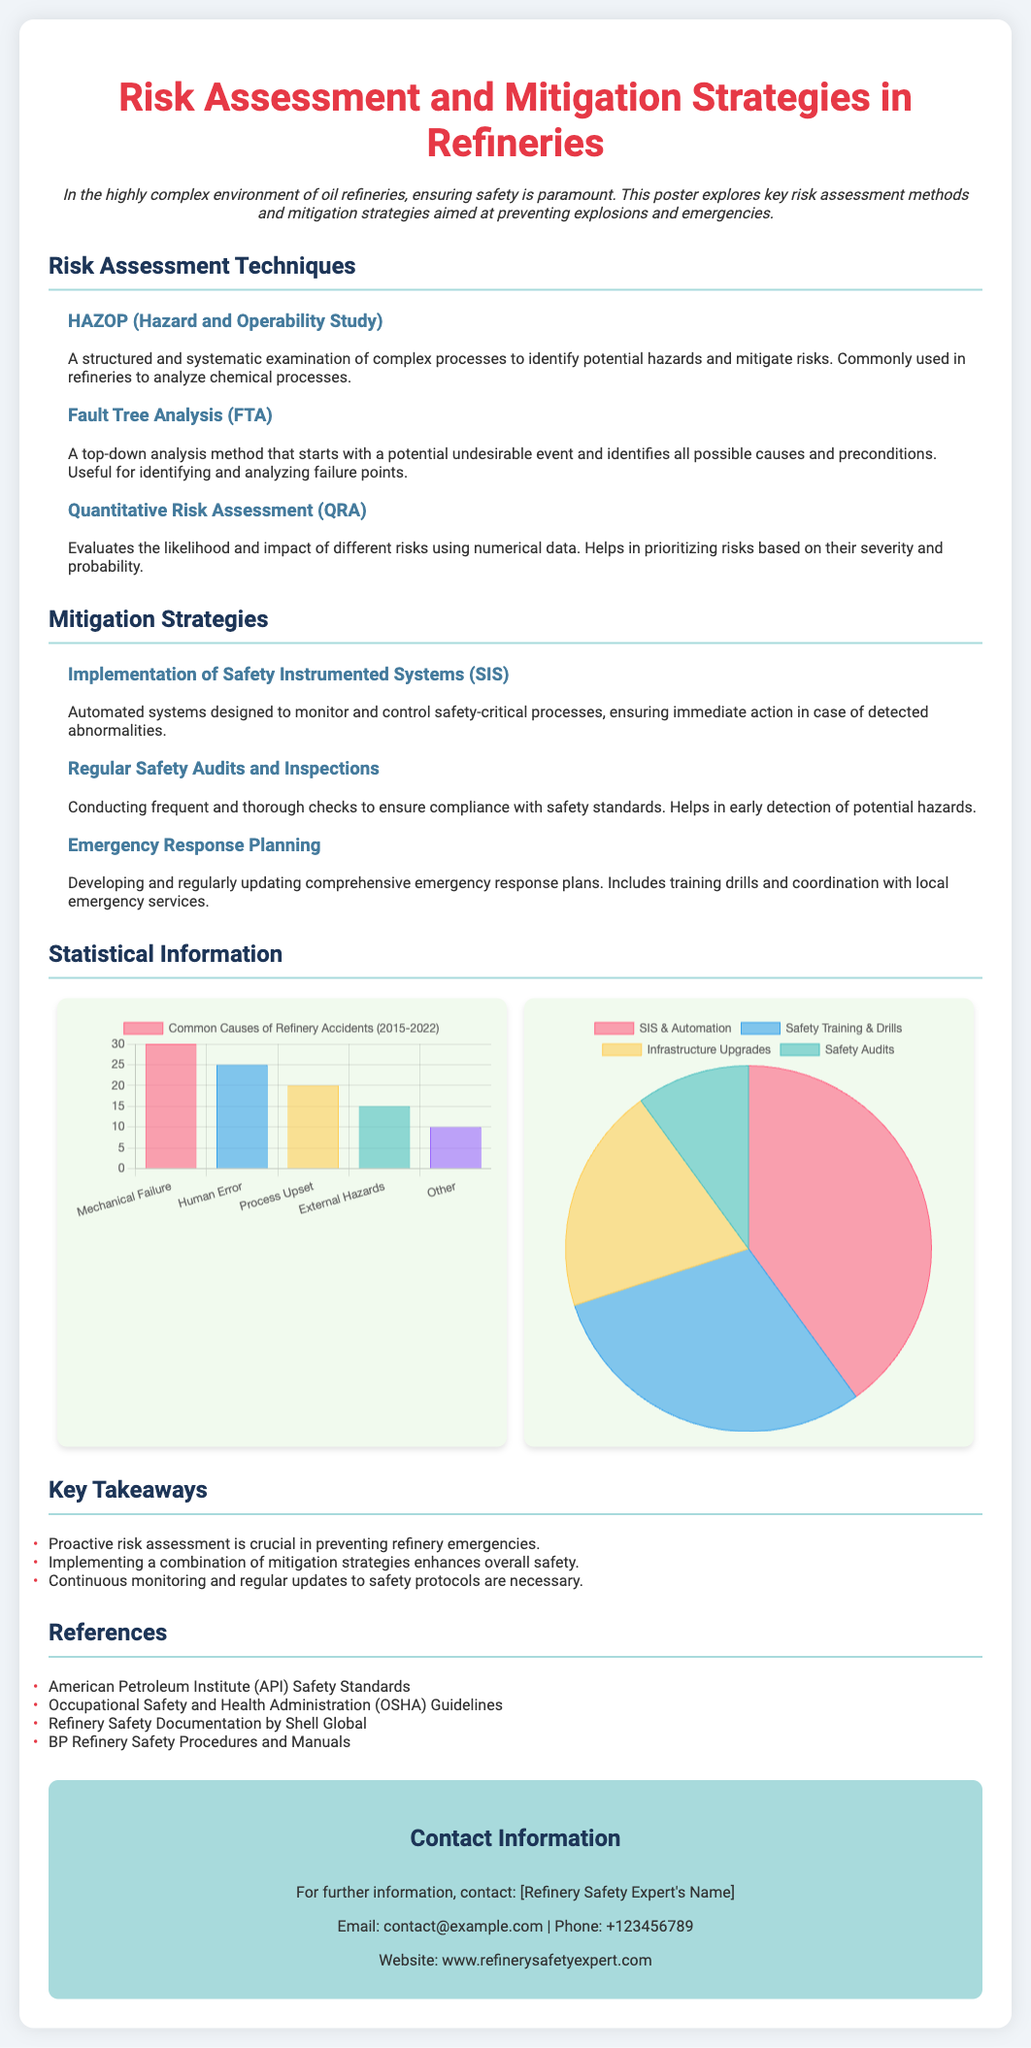What are the three risk assessment techniques mentioned? The poster lists HAZOP, Fault Tree Analysis (FTA), and Quantitative Risk Assessment (QRA) as the three risk assessment techniques.
Answer: HAZOP, Fault Tree Analysis (FTA), Quantitative Risk Assessment (QRA) What does SIS stand for in mitigation strategies? SIS refers to Safety Instrumented Systems, which are automated systems designed to monitor and control safety-critical processes.
Answer: Safety Instrumented Systems What percentage of risk mitigation investments is allocated to Safety Training & Drills? The poster states that 30% of risk mitigation investments are allocated to Safety Training & Drills.
Answer: 30% What is the most common cause of refinery accidents according to the bar chart? The bar chart indicates that Mechanical Failure is the most common cause of refinery accidents.
Answer: Mechanical Failure How many safety-related references are listed in the document? The document lists four references related to safety standards and practices in refineries.
Answer: Four What is the primary purpose of the poster? The primary purpose of the poster is to explore key risk assessment methods and mitigation strategies aimed at preventing explosions and emergencies in refineries.
Answer: Preventing explosions and emergencies What is the color scheme used for the background of the poster? The background color of the poster is a light shade, specifically #f0f4f8, providing a clean and professional look.
Answer: Light shade Which year range is covered in the common causes of refinery accidents data? The data in the bar chart covers the years 2015 to 2022 for common causes of refinery accidents.
Answer: 2015-2022 